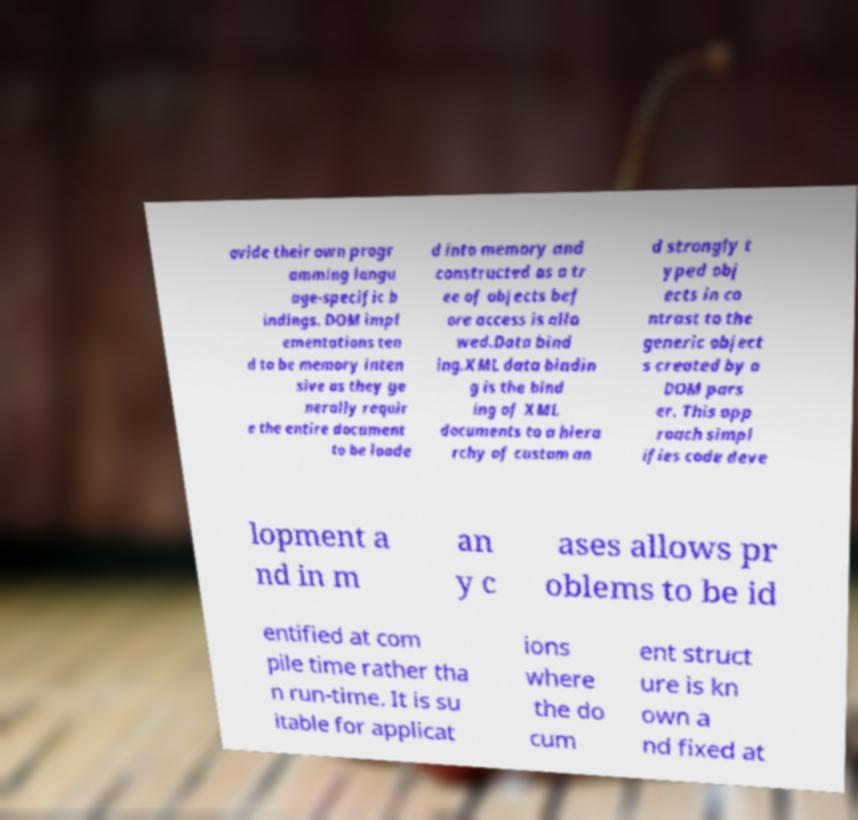Please identify and transcribe the text found in this image. ovide their own progr amming langu age-specific b indings. DOM impl ementations ten d to be memory inten sive as they ge nerally requir e the entire document to be loade d into memory and constructed as a tr ee of objects bef ore access is allo wed.Data bind ing.XML data bindin g is the bind ing of XML documents to a hiera rchy of custom an d strongly t yped obj ects in co ntrast to the generic object s created by a DOM pars er. This app roach simpl ifies code deve lopment a nd in m an y c ases allows pr oblems to be id entified at com pile time rather tha n run-time. It is su itable for applicat ions where the do cum ent struct ure is kn own a nd fixed at 